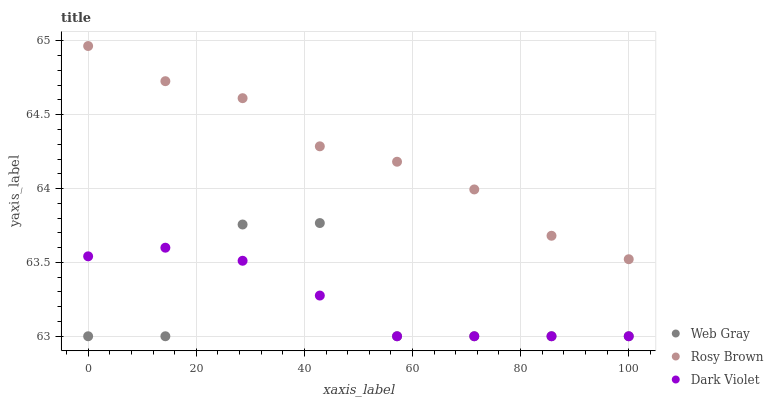Does Web Gray have the minimum area under the curve?
Answer yes or no. Yes. Does Rosy Brown have the maximum area under the curve?
Answer yes or no. Yes. Does Dark Violet have the minimum area under the curve?
Answer yes or no. No. Does Dark Violet have the maximum area under the curve?
Answer yes or no. No. Is Dark Violet the smoothest?
Answer yes or no. Yes. Is Web Gray the roughest?
Answer yes or no. Yes. Is Web Gray the smoothest?
Answer yes or no. No. Is Dark Violet the roughest?
Answer yes or no. No. Does Web Gray have the lowest value?
Answer yes or no. Yes. Does Rosy Brown have the highest value?
Answer yes or no. Yes. Does Web Gray have the highest value?
Answer yes or no. No. Is Dark Violet less than Rosy Brown?
Answer yes or no. Yes. Is Rosy Brown greater than Dark Violet?
Answer yes or no. Yes. Does Web Gray intersect Dark Violet?
Answer yes or no. Yes. Is Web Gray less than Dark Violet?
Answer yes or no. No. Is Web Gray greater than Dark Violet?
Answer yes or no. No. Does Dark Violet intersect Rosy Brown?
Answer yes or no. No. 